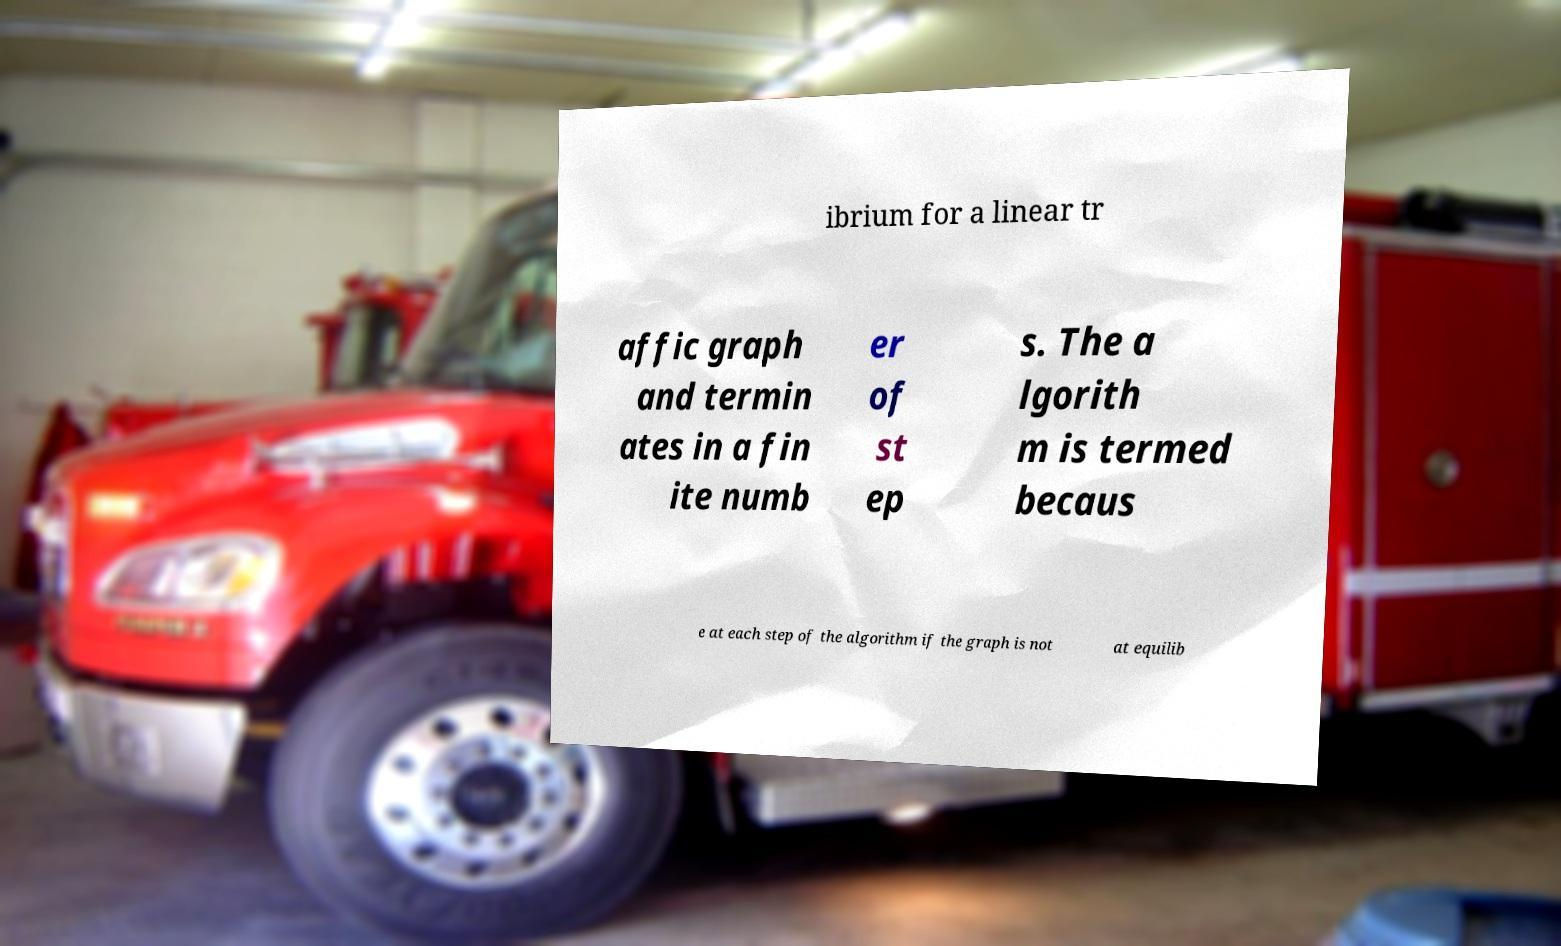What messages or text are displayed in this image? I need them in a readable, typed format. ibrium for a linear tr affic graph and termin ates in a fin ite numb er of st ep s. The a lgorith m is termed becaus e at each step of the algorithm if the graph is not at equilib 